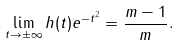Convert formula to latex. <formula><loc_0><loc_0><loc_500><loc_500>\lim _ { t \to \pm \infty } h ( t ) e ^ { - t ^ { 2 } } = \frac { m - 1 } { m } .</formula> 